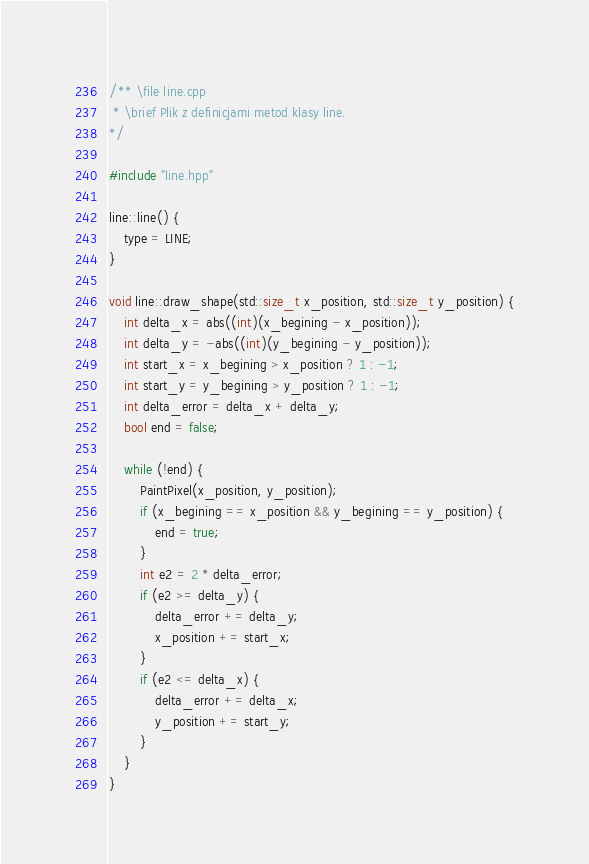<code> <loc_0><loc_0><loc_500><loc_500><_C++_>/** \file line.cpp
 * \brief Plik z definicjami metod klasy line.
*/

#include "line.hpp"

line::line() {
    type = LINE;
}

void line::draw_shape(std::size_t x_position, std::size_t y_position) {
    int delta_x = abs((int)(x_begining - x_position));
	int delta_y = -abs((int)(y_begining - y_position));
	int start_x = x_begining > x_position ? 1 : -1;
	int start_y = y_begining > y_position ? 1 : -1;
	int delta_error = delta_x + delta_y;
	bool end = false;

	while (!end) {
		PaintPixel(x_position, y_position);
		if (x_begining == x_position && y_begining == y_position) {
			end = true;
		}
		int e2 = 2 * delta_error;
		if (e2 >= delta_y) {
			delta_error += delta_y;
			x_position += start_x;
		}
		if (e2 <= delta_x) {
			delta_error += delta_x;
			y_position += start_y;
		}
	}
}
</code> 